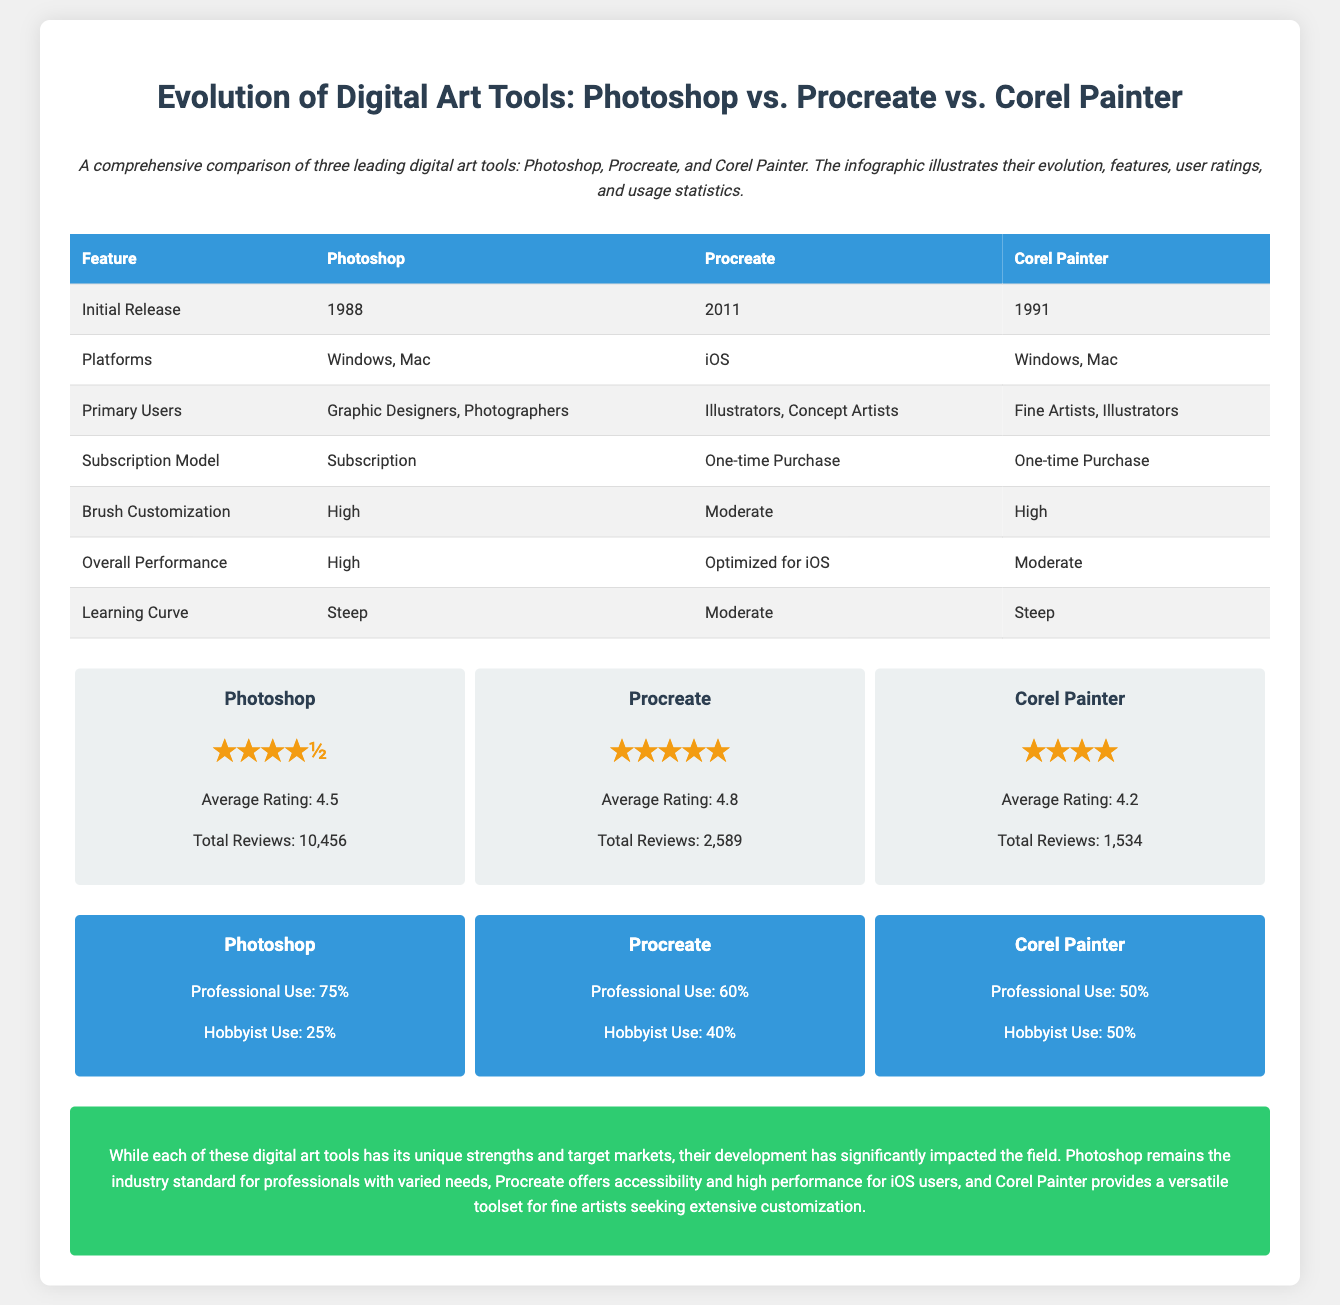What year was Photoshop initially released? The document states that Photoshop was initially released in 1988.
Answer: 1988 Which digital art tool has the highest average rating? The ratings section indicates that Procreate has the highest average rating of 4.8.
Answer: 4.8 What type of users primarily use Corel Painter? The document specifies that Corel Painter is primarily used by Fine Artists and Illustrators.
Answer: Fine Artists, Illustrators What is the subscription model for Photoshop? The table outlines that Photoshop follows a subscription model.
Answer: Subscription Which tool is optimized for iOS? The overall performance section highlights that Procreate is optimized for iOS.
Answer: Procreate What percentage of Procreate users are hobbyists? According to the usage statistics, 40% of Procreate users are hobbyists.
Answer: 40% Which tool has the steepest learning curve? The learning curve comparison shows that both Photoshop and Corel Painter have a steep learning curve.
Answer: Steep What is the primary platform for Procreate? The document lists iOS as the primary platform for Procreate.
Answer: iOS Which tool allows for high brush customization? The feature table indicates that both Photoshop and Corel Painter allow for high brush customization.
Answer: Photoshop, Corel Painter 